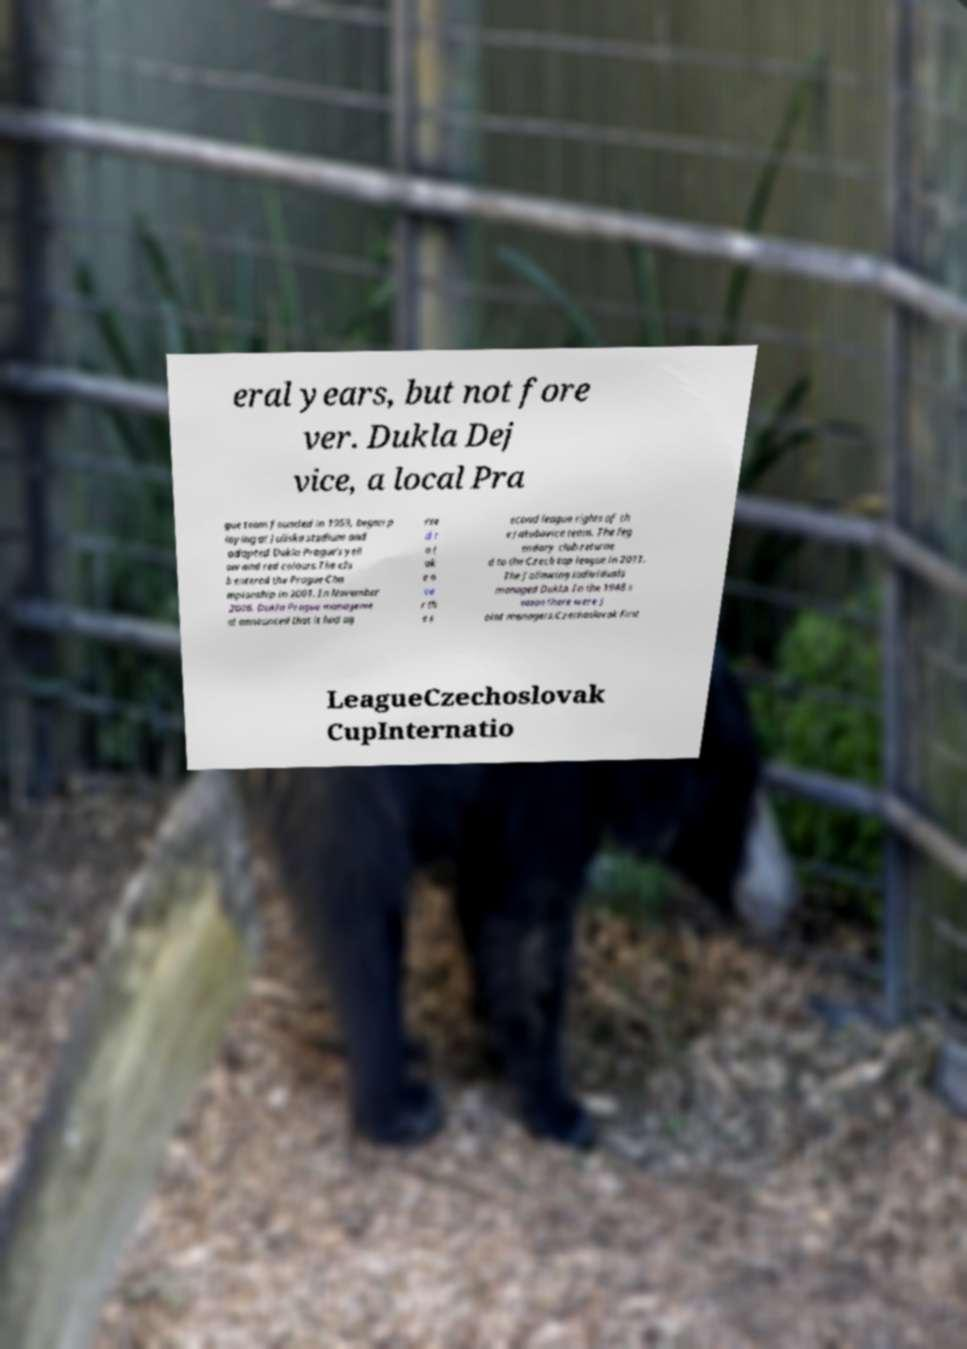Could you extract and type out the text from this image? eral years, but not fore ver. Dukla Dej vice, a local Pra gue team founded in 1959, began p laying at Juliska stadium and adopted Dukla Prague's yell ow and red colours.The clu b entered the Prague Cha mpionship in 2001. In November 2006, Dukla Prague manageme nt announced that it had ag ree d t o t ak e o ve r th e s econd league rights of th e Jakubovice team. The leg endary club returne d to the Czech top league in 2011. The following individuals managed Dukla. In the 1948 s eason there were j oint managers.Czechoslovak First LeagueCzechoslovak CupInternatio 